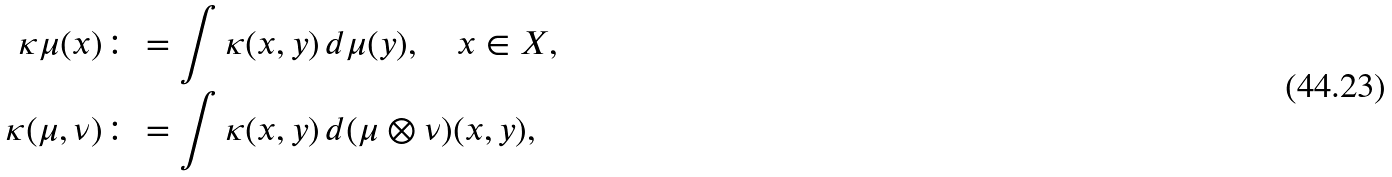Convert formula to latex. <formula><loc_0><loc_0><loc_500><loc_500>\kappa \mu ( x ) & \colon = \int \kappa ( x , y ) \, d \mu ( y ) , \quad x \in X , \\ \kappa ( \mu , \nu ) & \colon = \int \kappa ( x , y ) \, d ( \mu \otimes \nu ) ( x , y ) ,</formula> 